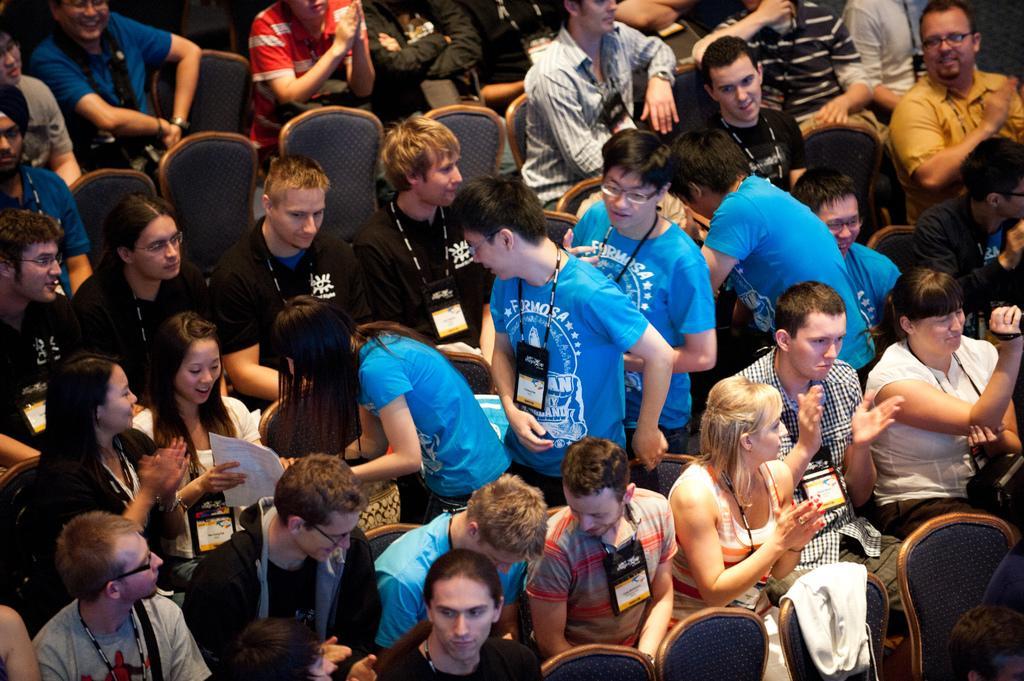Can you describe this image briefly? This image is taken indoors. In this image many people are sitting on the chairs and a few are standing on the floor. At the bottom of the image there are four empty chairs. A few people are holding papers in their hands and a few people are clapping their hands. 